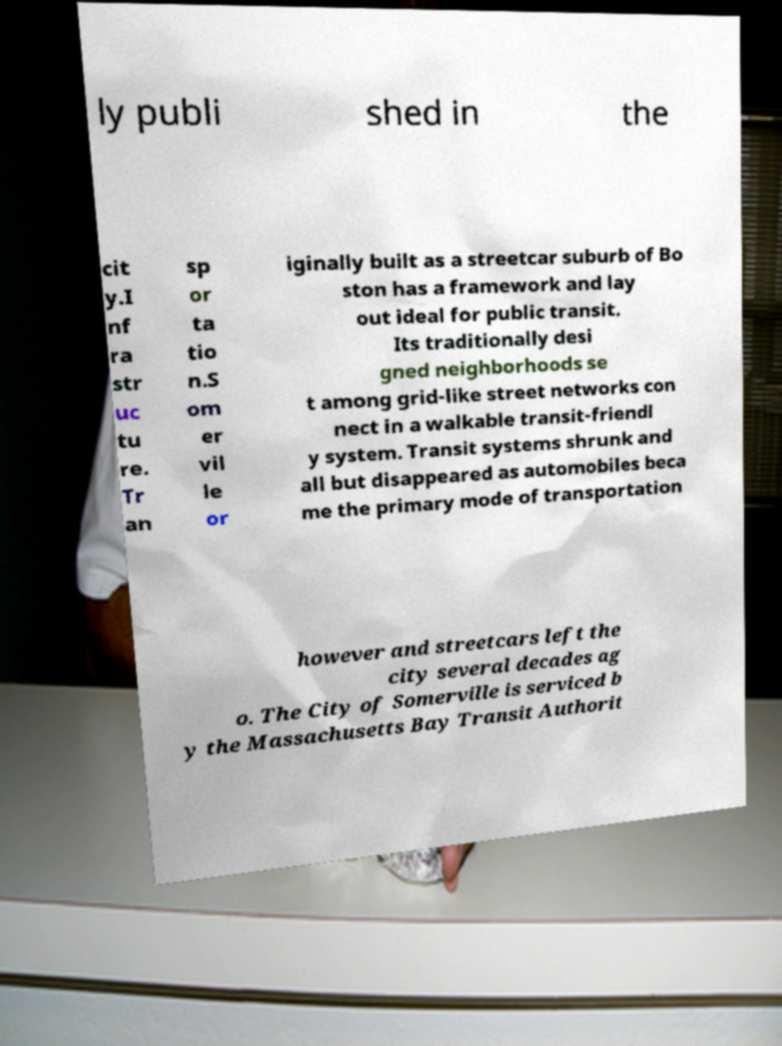Could you assist in decoding the text presented in this image and type it out clearly? ly publi shed in the cit y.I nf ra str uc tu re. Tr an sp or ta tio n.S om er vil le or iginally built as a streetcar suburb of Bo ston has a framework and lay out ideal for public transit. Its traditionally desi gned neighborhoods se t among grid-like street networks con nect in a walkable transit-friendl y system. Transit systems shrunk and all but disappeared as automobiles beca me the primary mode of transportation however and streetcars left the city several decades ag o. The City of Somerville is serviced b y the Massachusetts Bay Transit Authorit 